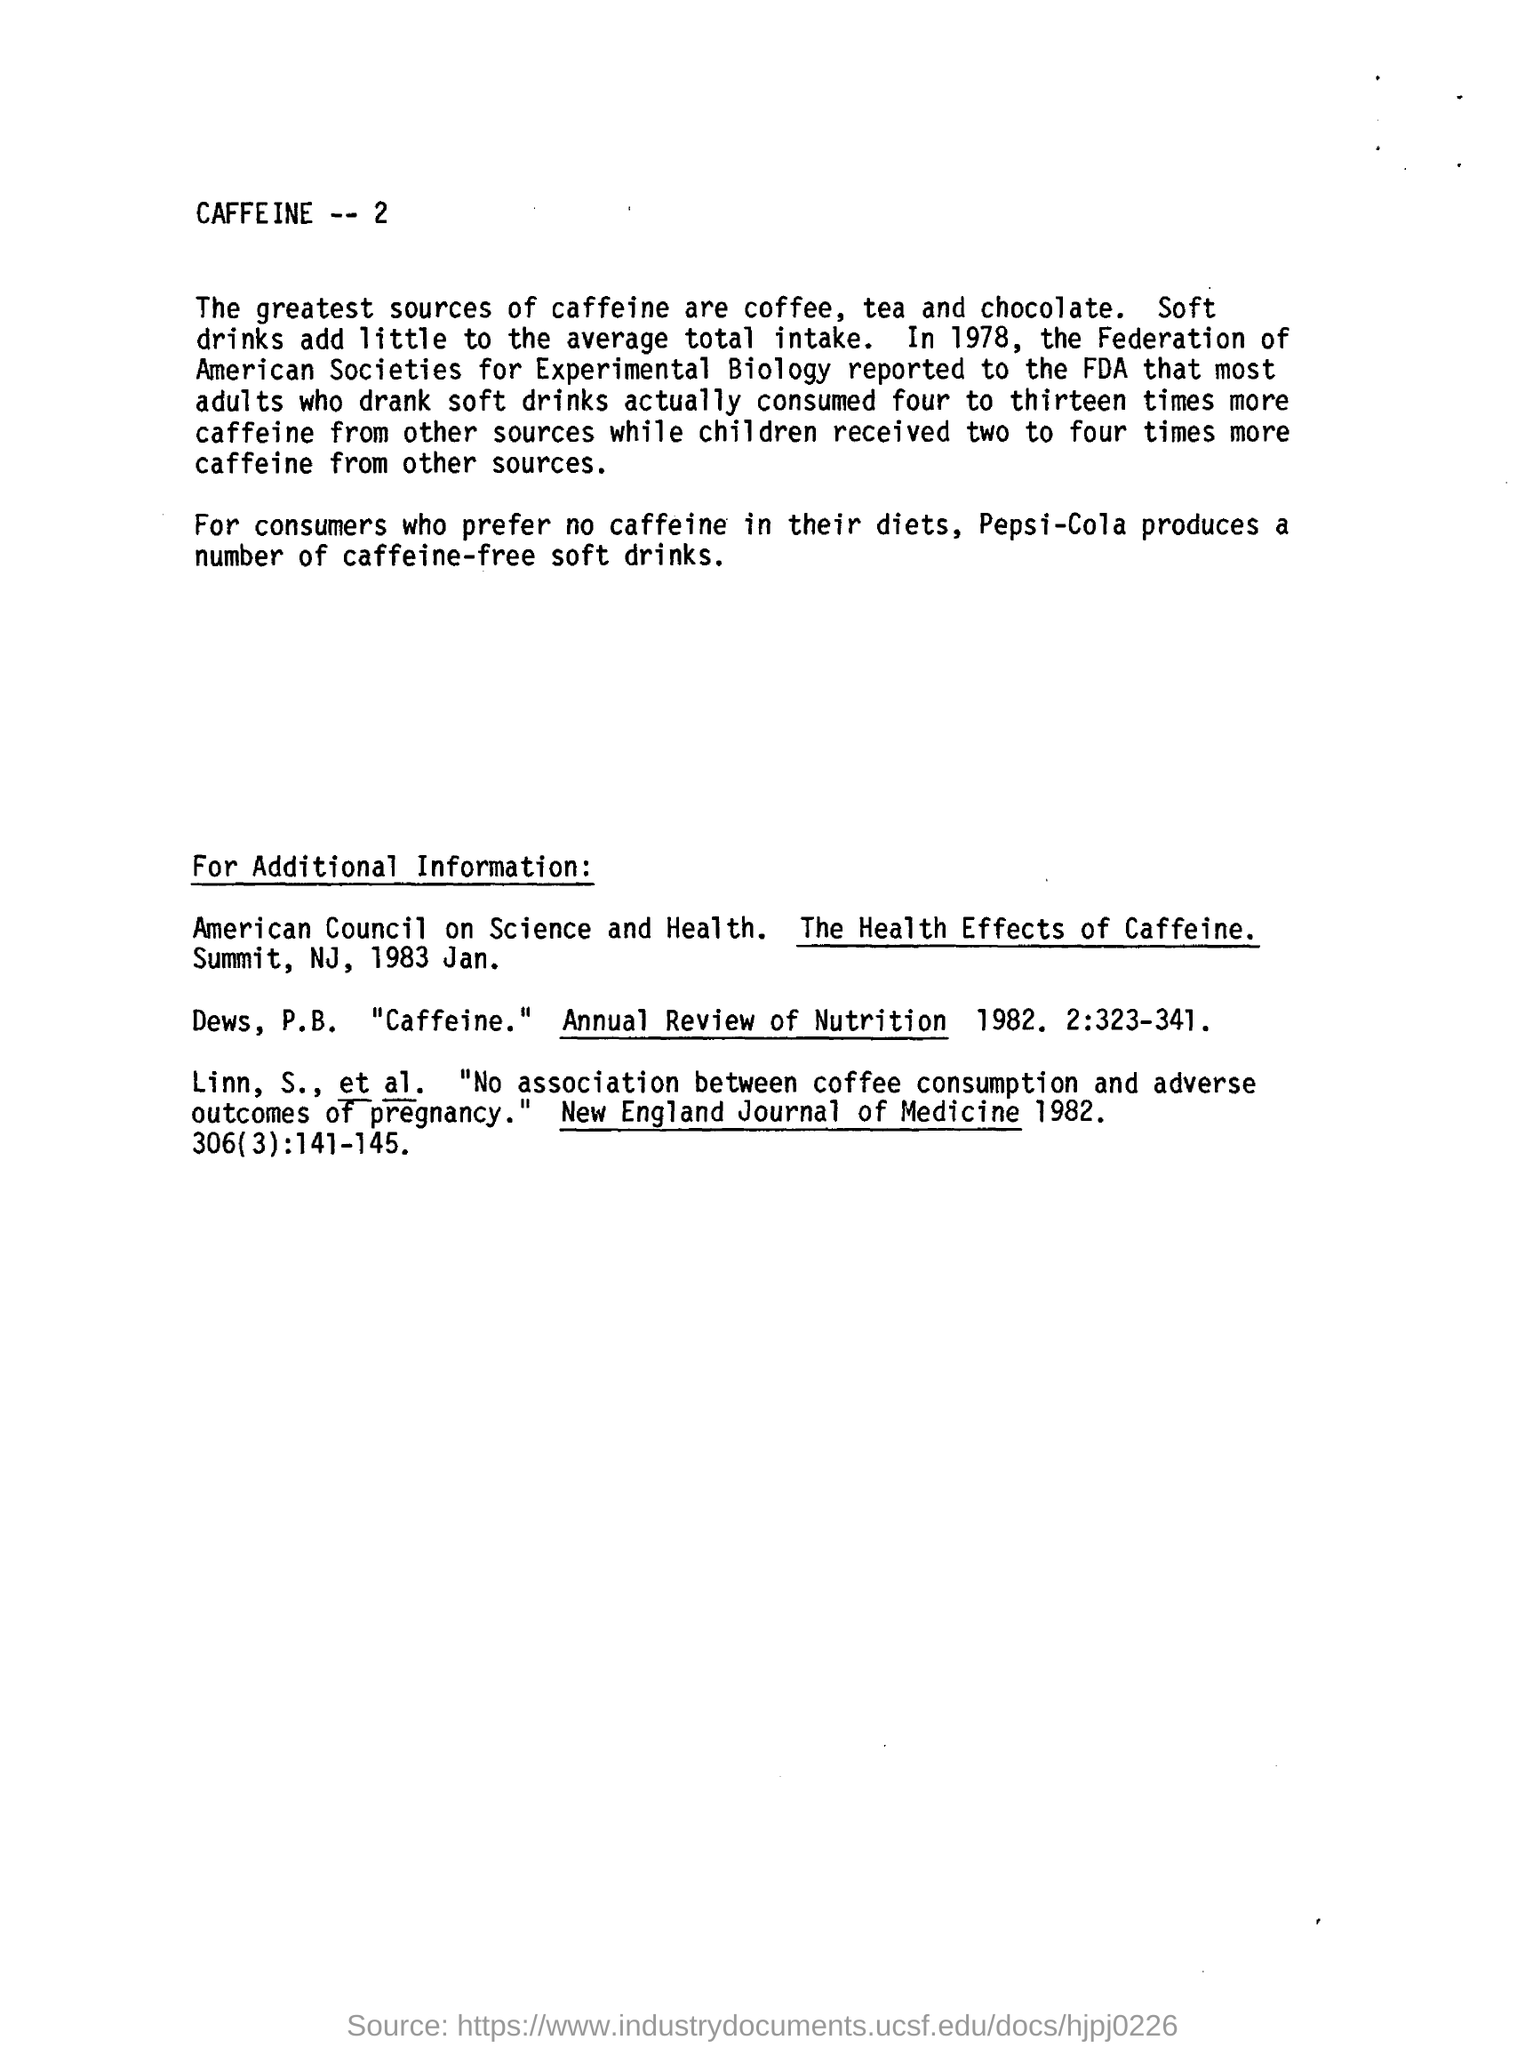Give some essential details in this illustration. Coffee, tea, and chocolate are the greatest sources of caffeine. Pepsi-Cola offers a variety of caffeine-free soft drink options for individuals who prefer to consume beverages without caffeine in their diets. The American Council on Science and Health published a report titled "The Health Effects of Caffeine" in 1983. Soft drinks contribute a minimal amount to the overall caffeine consumption. 